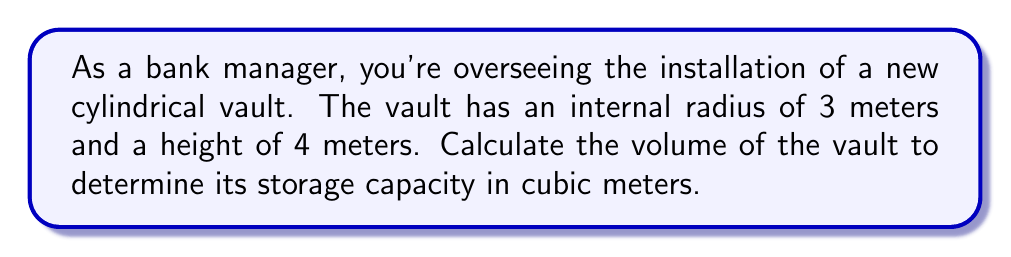Teach me how to tackle this problem. To calculate the volume of a cylindrical vault, we use the formula for the volume of a cylinder:

$$V = \pi r^2 h$$

Where:
$V$ = volume
$r$ = radius of the base
$h$ = height of the cylinder

Given:
$r = 3$ meters
$h = 4$ meters

Let's substitute these values into the formula:

$$V = \pi (3\text{ m})^2 (4\text{ m})$$

Simplify:
$$V = \pi (9\text{ m}^2) (4\text{ m})$$
$$V = 36\pi\text{ m}^3$$

Using $\pi \approx 3.14159$, we can approximate the volume:

$$V \approx 36 (3.14159)\text{ m}^3$$
$$V \approx 113.09724\text{ m}^3$$

Rounding to two decimal places:
$$V \approx 113.10\text{ m}^3$$
Answer: $113.10\text{ m}^3$ 